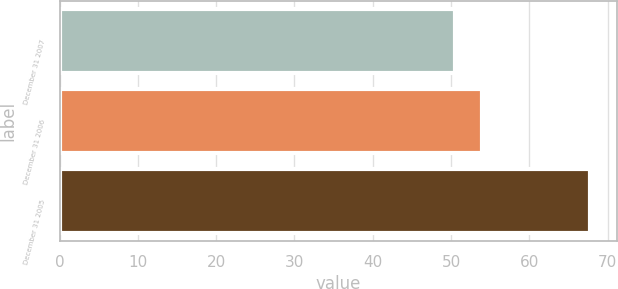Convert chart. <chart><loc_0><loc_0><loc_500><loc_500><bar_chart><fcel>December 31 2007<fcel>December 31 2006<fcel>December 31 2005<nl><fcel>50.5<fcel>53.9<fcel>67.8<nl></chart> 